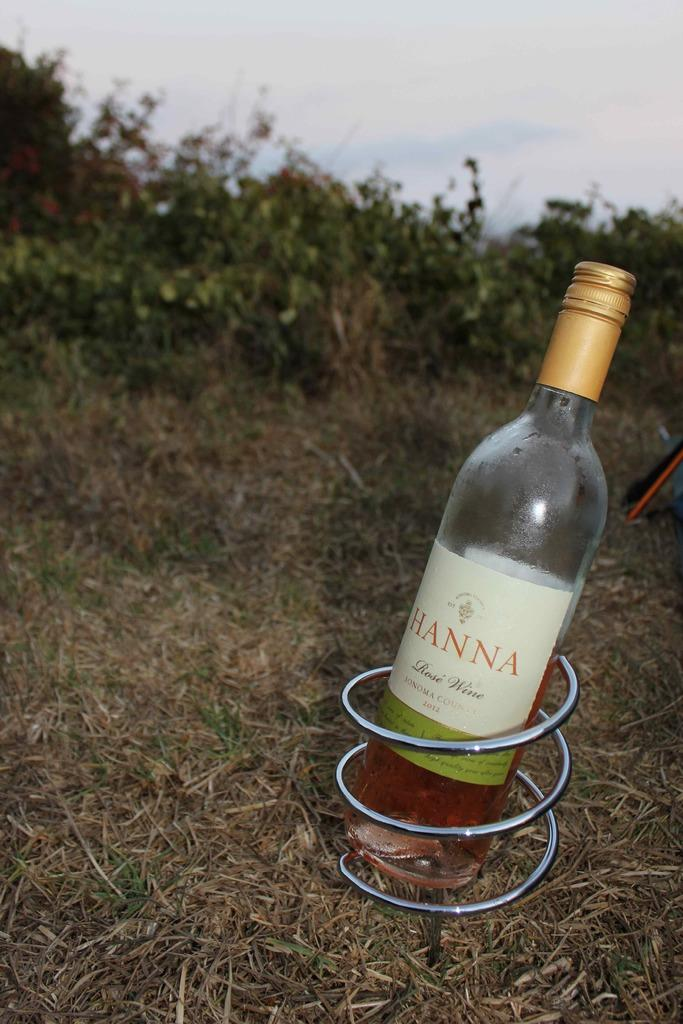<image>
Share a concise interpretation of the image provided. A bottle of Hanna rose wine on a grassy patch 